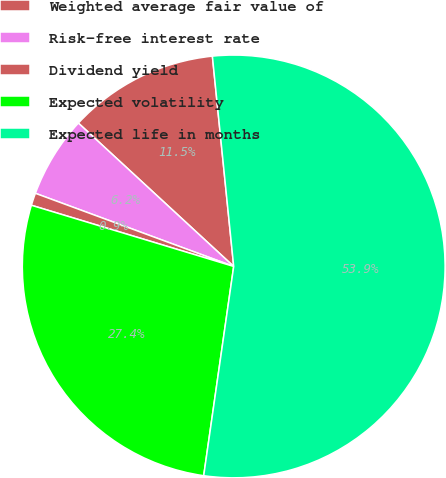Convert chart to OTSL. <chart><loc_0><loc_0><loc_500><loc_500><pie_chart><fcel>Weighted average fair value of<fcel>Risk-free interest rate<fcel>Dividend yield<fcel>Expected volatility<fcel>Expected life in months<nl><fcel>11.53%<fcel>6.24%<fcel>0.95%<fcel>27.41%<fcel>53.88%<nl></chart> 